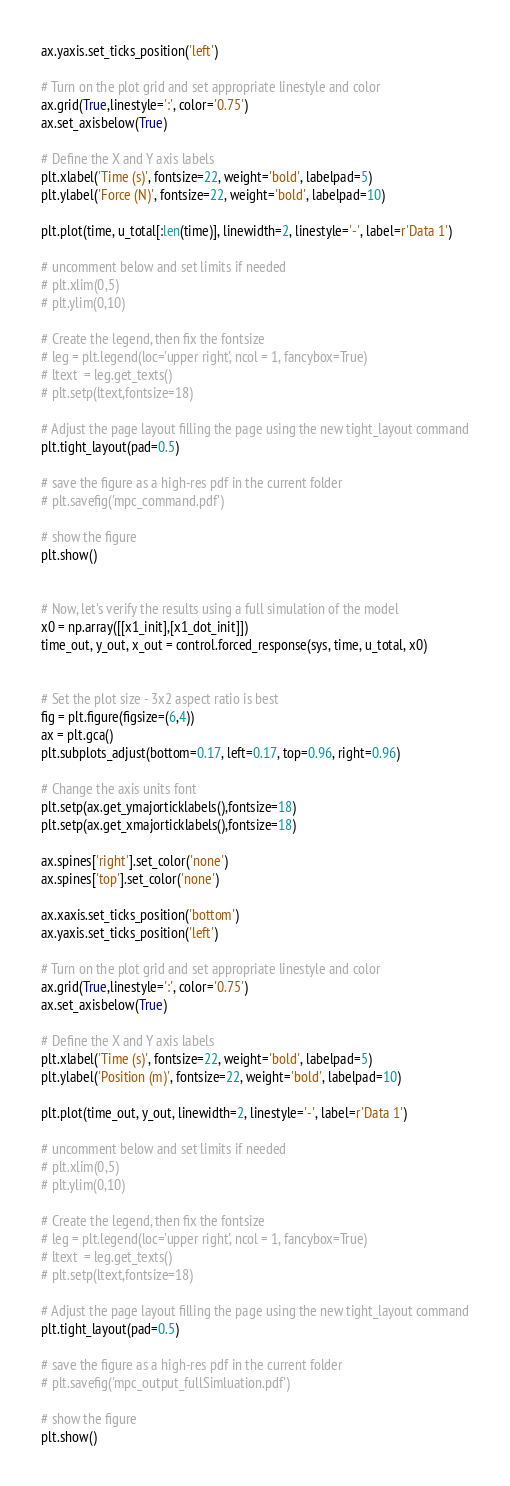Convert code to text. <code><loc_0><loc_0><loc_500><loc_500><_Python_>ax.yaxis.set_ticks_position('left')

# Turn on the plot grid and set appropriate linestyle and color
ax.grid(True,linestyle=':', color='0.75')
ax.set_axisbelow(True)

# Define the X and Y axis labels
plt.xlabel('Time (s)', fontsize=22, weight='bold', labelpad=5)
plt.ylabel('Force (N)', fontsize=22, weight='bold', labelpad=10)
 
plt.plot(time, u_total[:len(time)], linewidth=2, linestyle='-', label=r'Data 1')

# uncomment below and set limits if needed
# plt.xlim(0,5)
# plt.ylim(0,10)

# Create the legend, then fix the fontsize
# leg = plt.legend(loc='upper right', ncol = 1, fancybox=True)
# ltext  = leg.get_texts()
# plt.setp(ltext,fontsize=18)

# Adjust the page layout filling the page using the new tight_layout command
plt.tight_layout(pad=0.5)

# save the figure as a high-res pdf in the current folder
# plt.savefig('mpc_command.pdf')

# show the figure
plt.show()


# Now, let's verify the results using a full simulation of the model 
x0 = np.array([[x1_init],[x1_dot_init]])
time_out, y_out, x_out = control.forced_response(sys, time, u_total, x0)


# Set the plot size - 3x2 aspect ratio is best
fig = plt.figure(figsize=(6,4))
ax = plt.gca()
plt.subplots_adjust(bottom=0.17, left=0.17, top=0.96, right=0.96)

# Change the axis units font
plt.setp(ax.get_ymajorticklabels(),fontsize=18)
plt.setp(ax.get_xmajorticklabels(),fontsize=18)

ax.spines['right'].set_color('none')
ax.spines['top'].set_color('none')

ax.xaxis.set_ticks_position('bottom')
ax.yaxis.set_ticks_position('left')

# Turn on the plot grid and set appropriate linestyle and color
ax.grid(True,linestyle=':', color='0.75')
ax.set_axisbelow(True)

# Define the X and Y axis labels
plt.xlabel('Time (s)', fontsize=22, weight='bold', labelpad=5)
plt.ylabel('Position (m)', fontsize=22, weight='bold', labelpad=10)
 
plt.plot(time_out, y_out, linewidth=2, linestyle='-', label=r'Data 1')

# uncomment below and set limits if needed
# plt.xlim(0,5)
# plt.ylim(0,10)

# Create the legend, then fix the fontsize
# leg = plt.legend(loc='upper right', ncol = 1, fancybox=True)
# ltext  = leg.get_texts()
# plt.setp(ltext,fontsize=18)

# Adjust the page layout filling the page using the new tight_layout command
plt.tight_layout(pad=0.5)

# save the figure as a high-res pdf in the current folder
# plt.savefig('mpc_output_fullSimluation.pdf')

# show the figure
plt.show()
</code> 